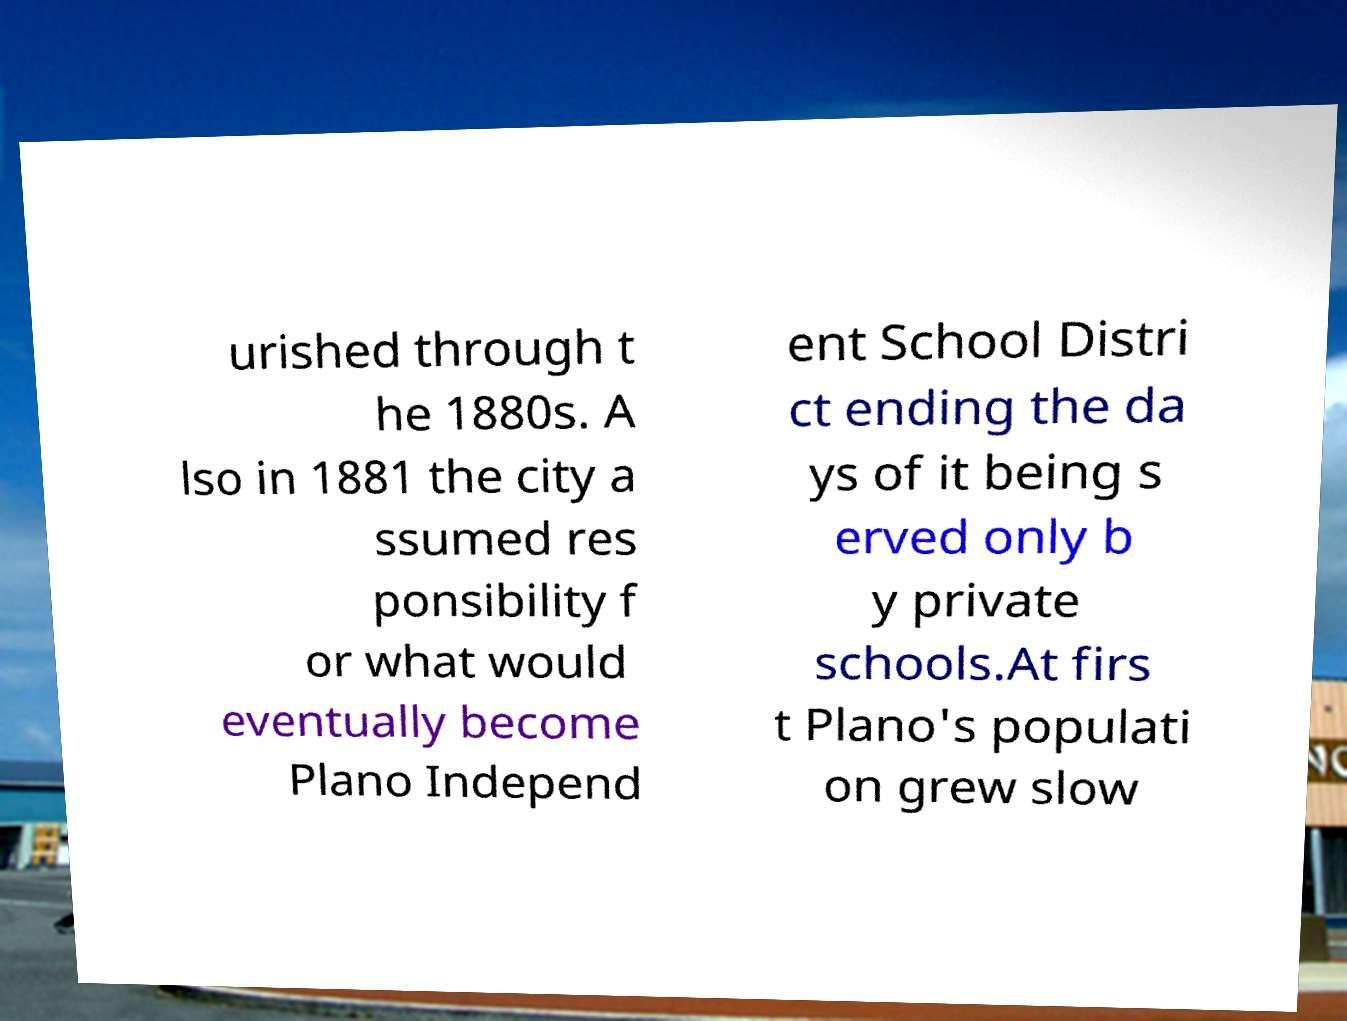Could you extract and type out the text from this image? urished through t he 1880s. A lso in 1881 the city a ssumed res ponsibility f or what would eventually become Plano Independ ent School Distri ct ending the da ys of it being s erved only b y private schools.At firs t Plano's populati on grew slow 